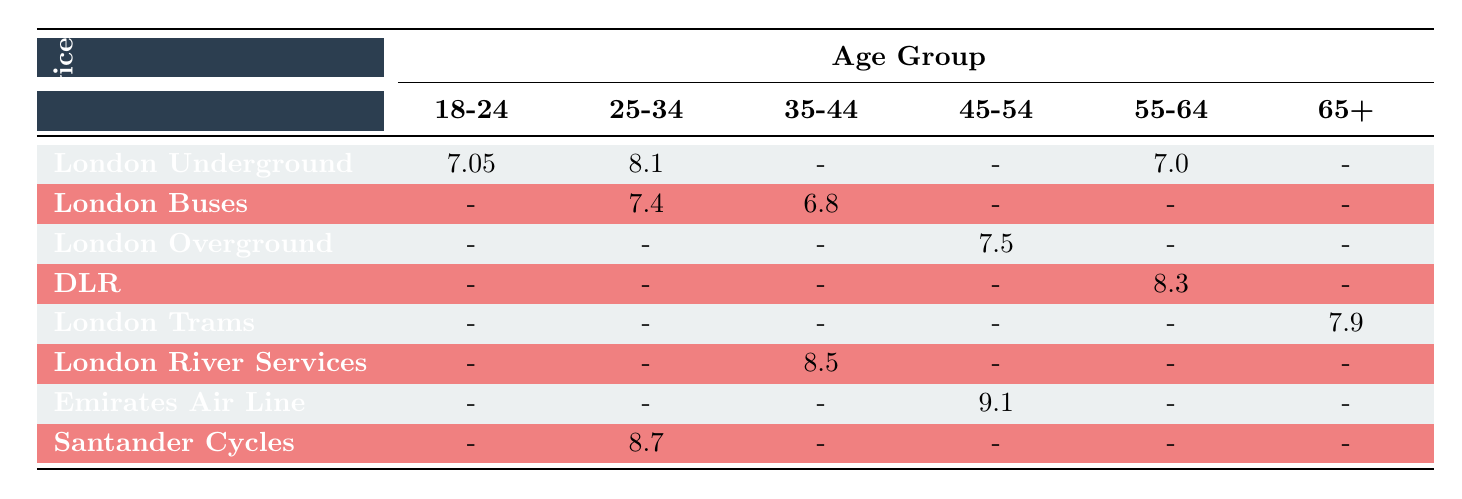What is the satisfaction score for London Underground among the 25-34 age group? The table shows that the satisfaction score for London Underground for the 25-34 age group is 8.1.
Answer: 8.1 Which transport service has the highest satisfaction score from the 65+ age group? According to the table, London Trams has a satisfaction score of 7.9 from the 65+ age group, and this is higher than any other service listed for that age group.
Answer: London Trams What is the average satisfaction score for the 18-24 age group across all services? The scores for the 18-24 age group are 7.2 (London Underground) and 6.9 (London Underground). Adding them gives 14.1, and dividing by 2 provides the average: 14.1/2 = 7.05.
Answer: 7.05 Do all services have a satisfaction score recorded for the 45-54 age group? By examining the table, it is clear that not all services have scores for the 45-54 age group; specifically, London Underground and London Buses are missing scores.
Answer: No Which age group has the highest satisfaction score for the DLR service? The DLR service's only recorded score is 8.3 for the 55-64 age group, which is the highest as there are no other scores available for different age groups since the rest are marked as missing.
Answer: 8.3 What is the difference in satisfaction scores between the best-rated service and the worst-rated service in the category of Cleanliness? Referring to the table, the best score in Cleanliness is 8.1 for London Underground (25-34 age group), while there is no recorded score for any other services in that category. Since there’s only one score, the difference cannot be calculated meaningfully.
Answer: N/A What is the satisfaction score for London River Services in the 35-44 age group? The table indicates a satisfaction score of 8.5 for London River Services for the 35-44 age group.
Answer: 8.5 Are there any services that have no satisfaction scores for the 25-34 age group? Upon reviewing the table, both London Overground and DLR have no scores for the 25-34 age group, confirming that there are indeed services without scores for this age group.
Answer: Yes What is the average satisfaction score for the 55-64 age group across all transport services listed? The scores for the 55-64 age group are 7.0 (London Underground) and 8.3 (DLR). Adding these gives 15.3, and dividing by the 2 scores provides an average of 15.3/2 = 7.65.
Answer: 7.65 